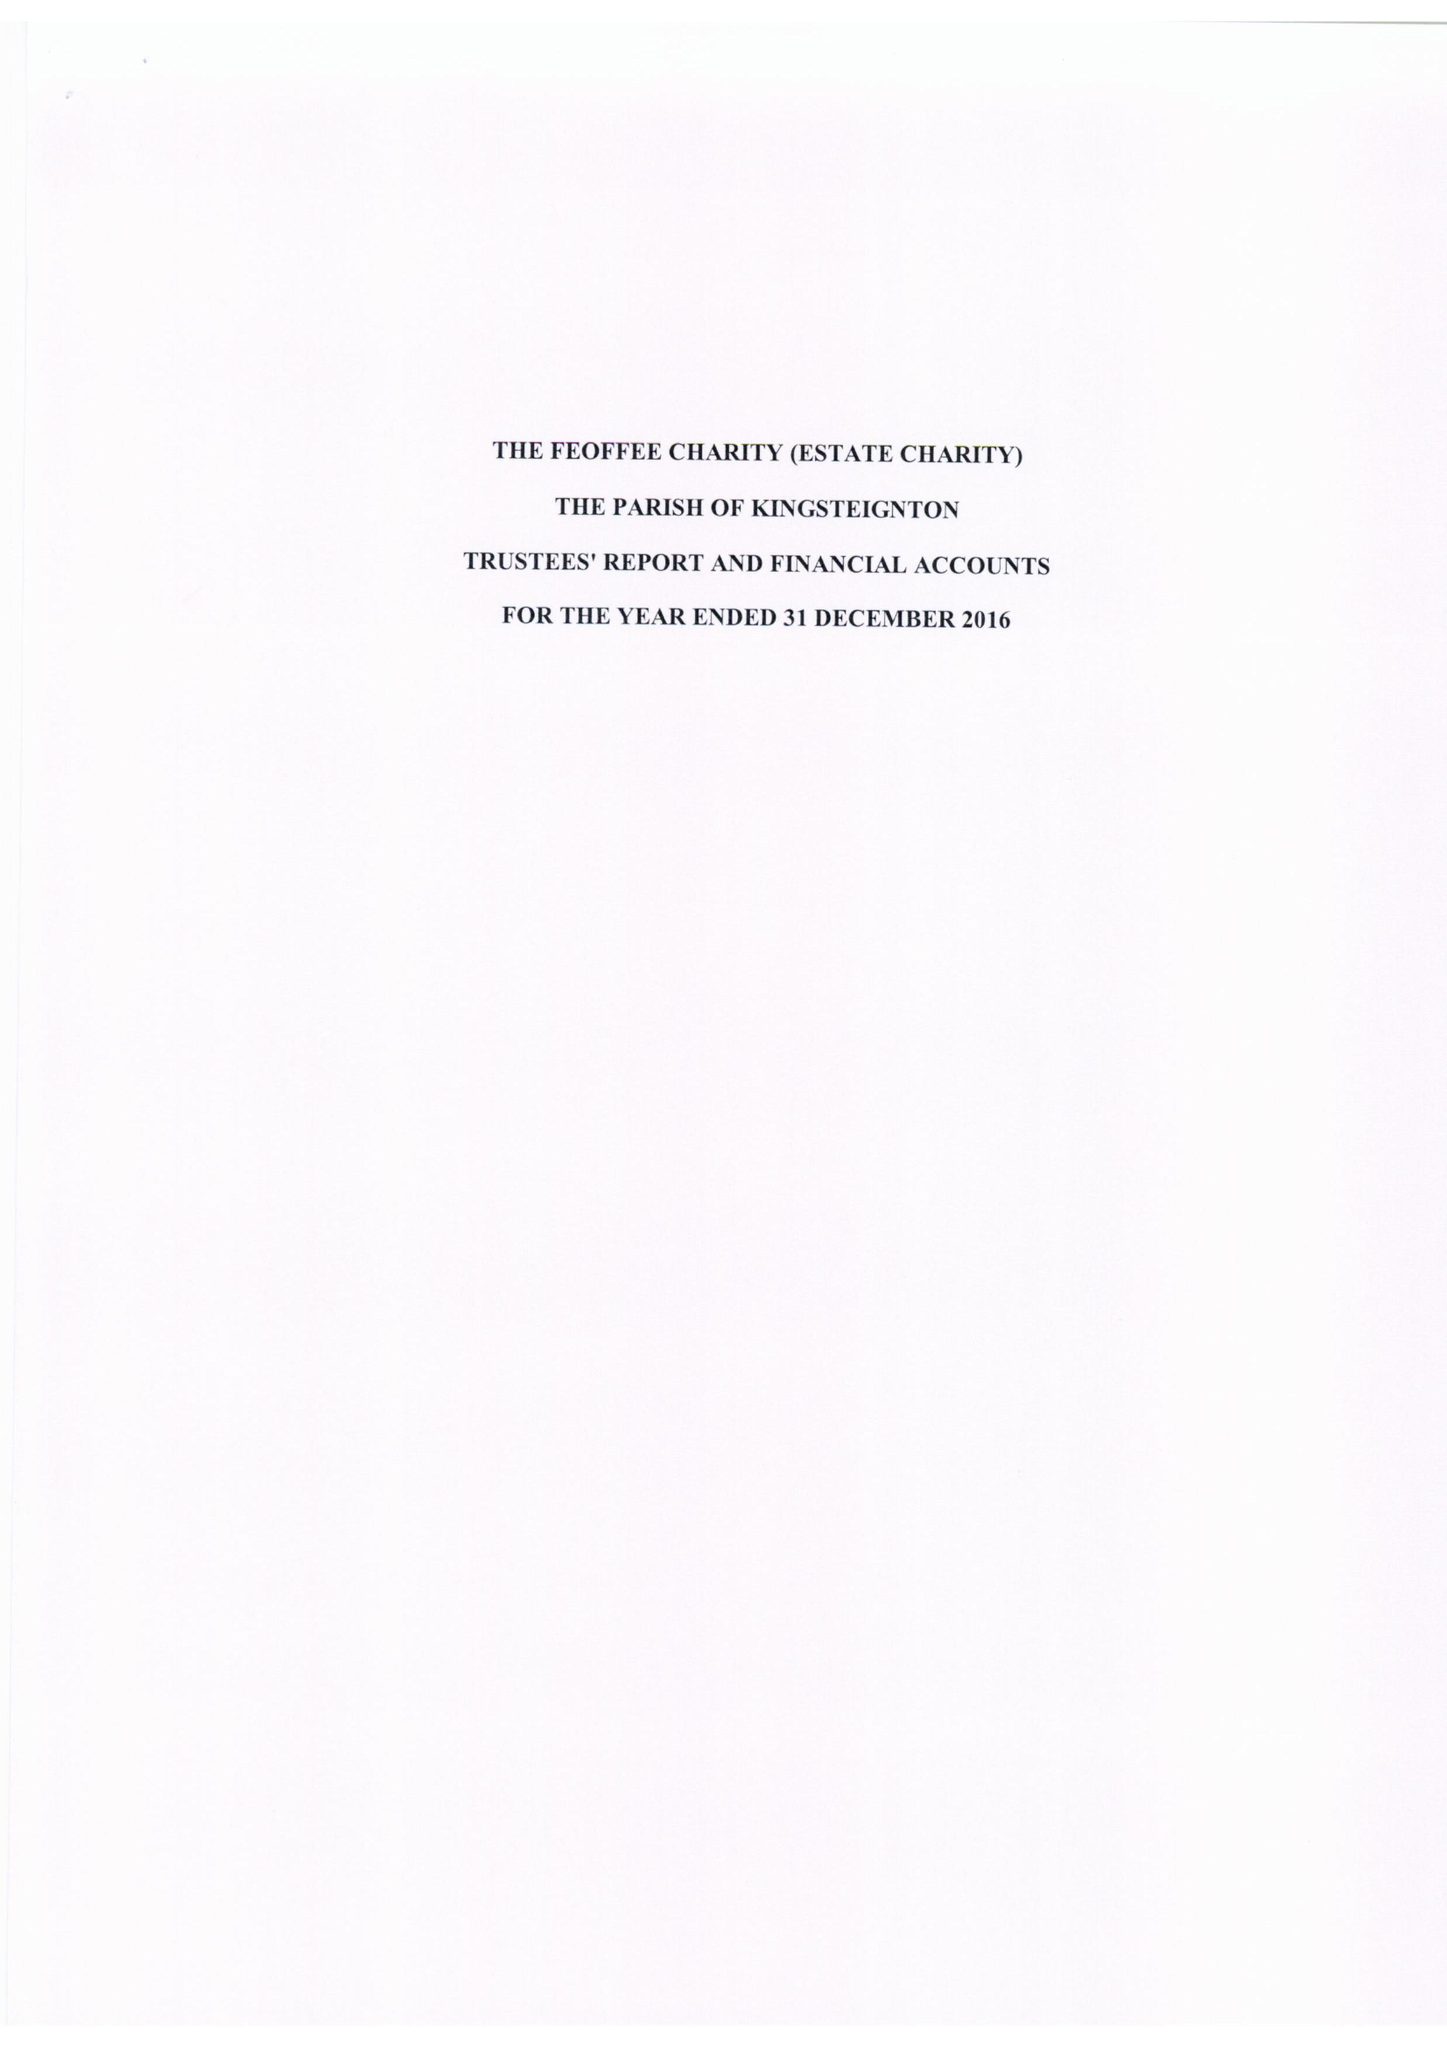What is the value for the address__post_town?
Answer the question using a single word or phrase. PAIGNTON 